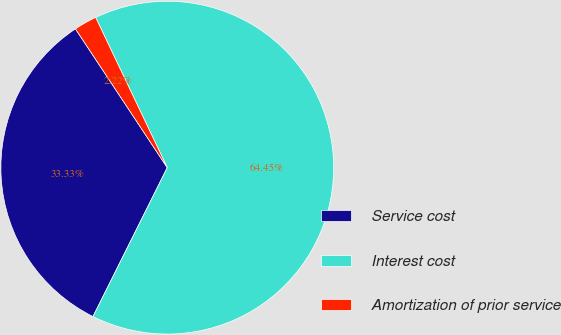<chart> <loc_0><loc_0><loc_500><loc_500><pie_chart><fcel>Service cost<fcel>Interest cost<fcel>Amortization of prior service<nl><fcel>33.33%<fcel>64.44%<fcel>2.22%<nl></chart> 